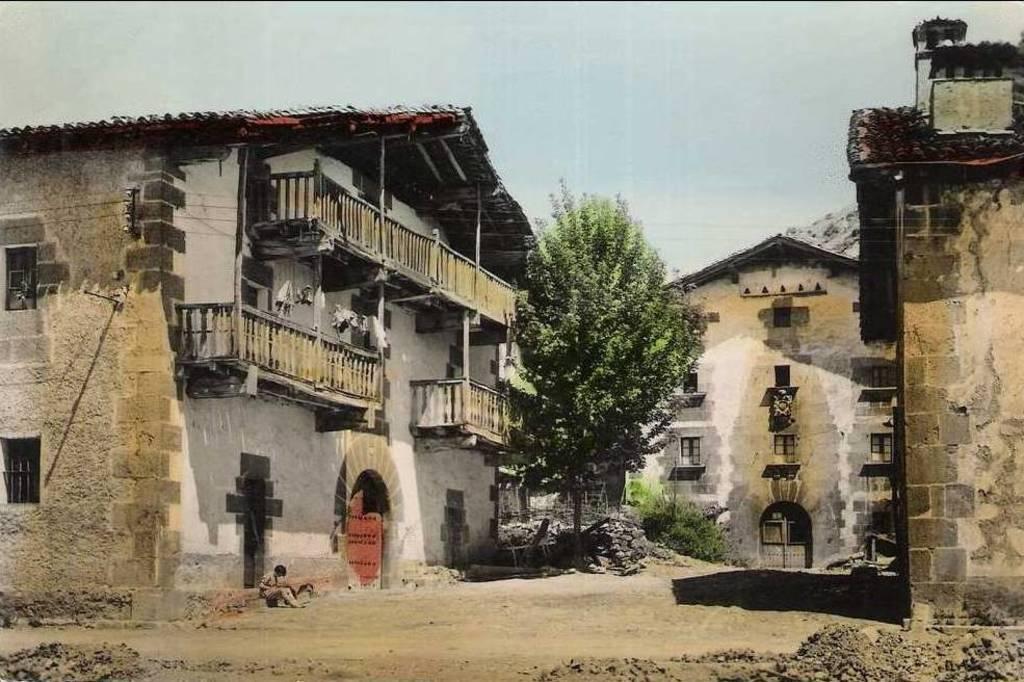How would you summarize this image in a sentence or two? Buildings with windows and doors. In-between of these buildings there is a tree and plants. 